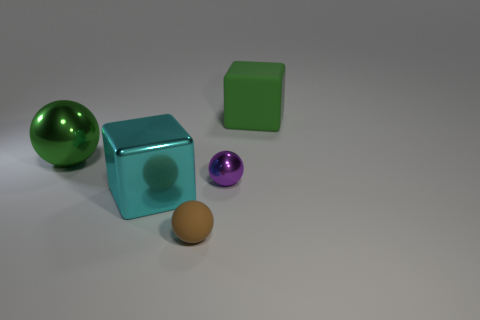Subtract all gray spheres. Subtract all yellow cylinders. How many spheres are left? 3 Add 5 big red metallic balls. How many objects exist? 10 Subtract all balls. How many objects are left? 2 Subtract all purple metallic blocks. Subtract all big balls. How many objects are left? 4 Add 1 large matte things. How many large matte things are left? 2 Add 5 small purple spheres. How many small purple spheres exist? 6 Subtract 0 red cylinders. How many objects are left? 5 